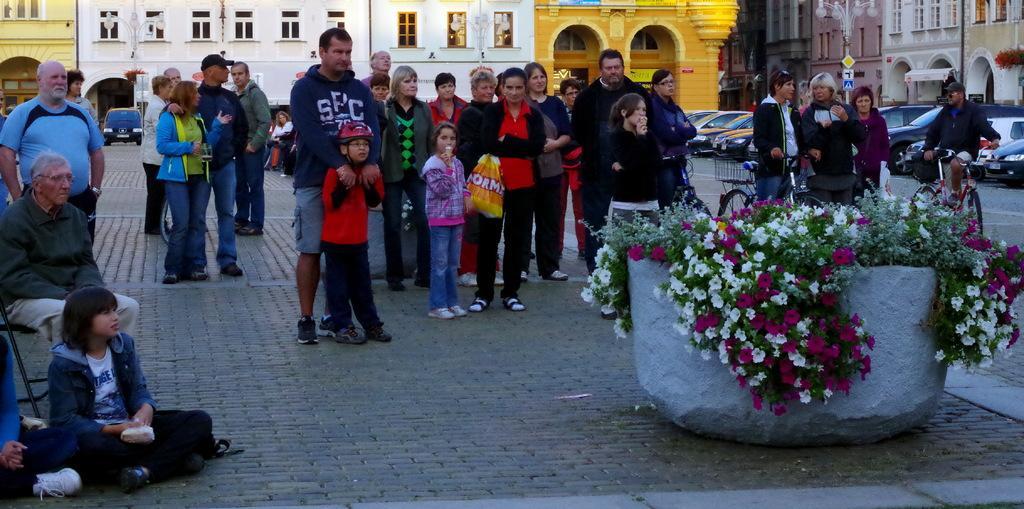In one or two sentences, can you explain what this image depicts? In this image, we can see some people, buildings, vehicles, poles, boards. We can see the ground with some objects. We can also see an object with some plants and flowers. 